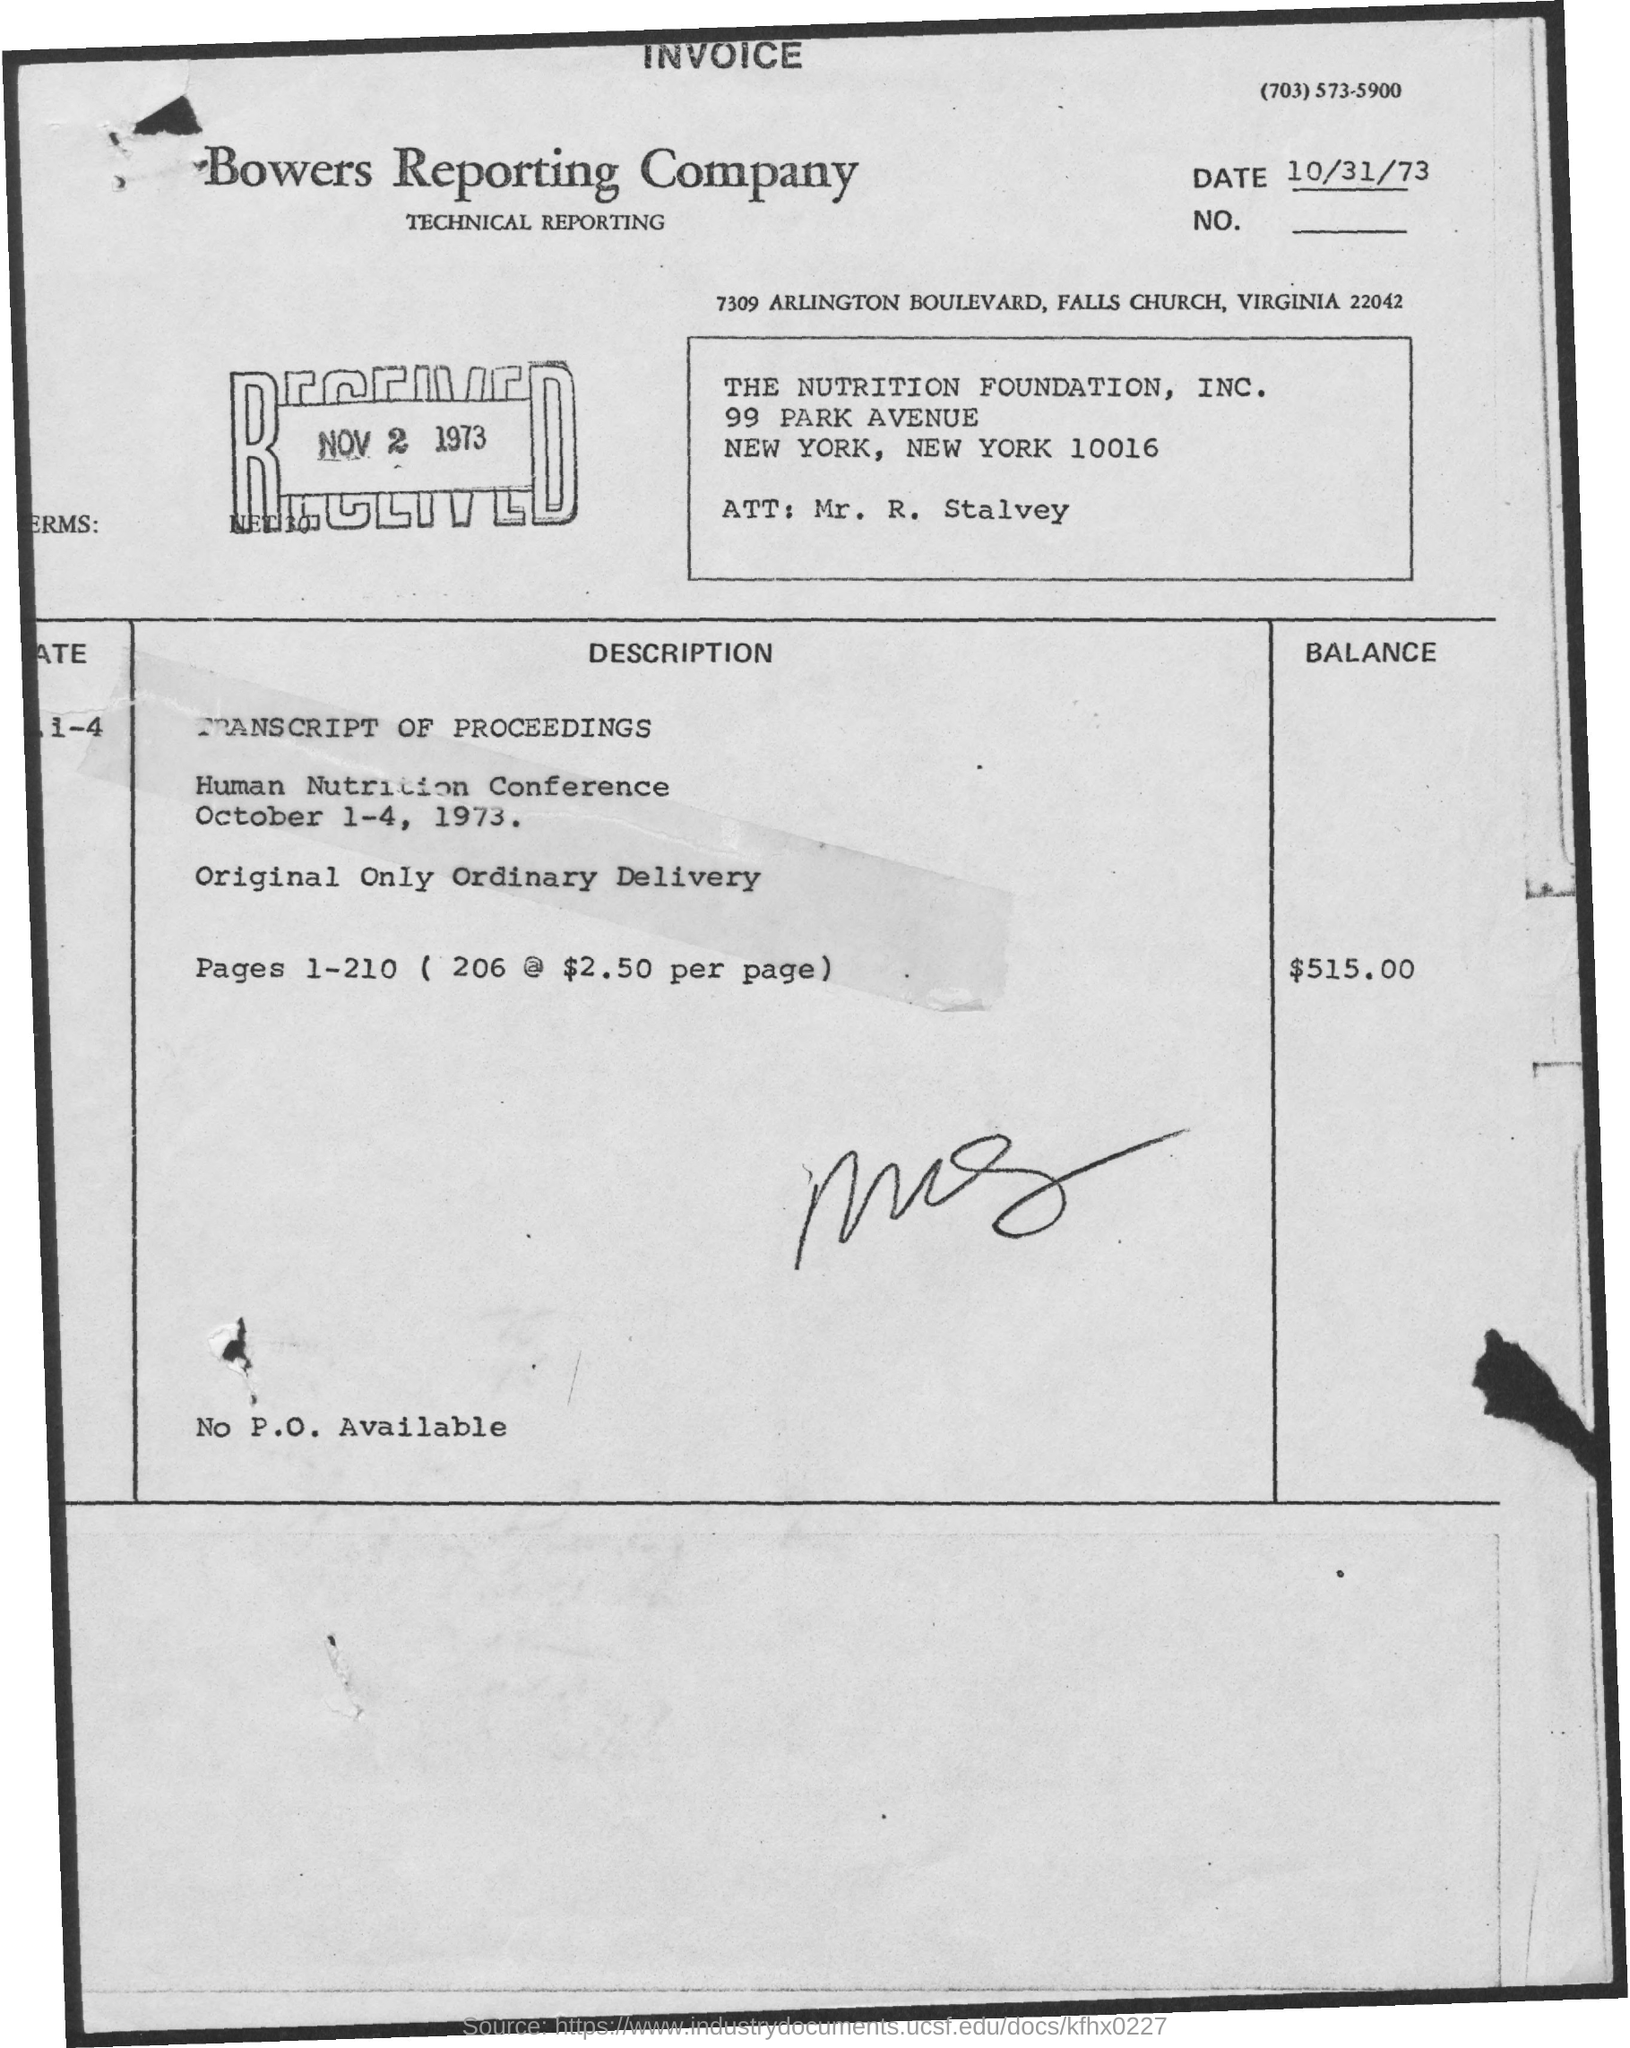Point out several critical features in this image. The balance amount is $515.00. The received date is November 2, 1973. 